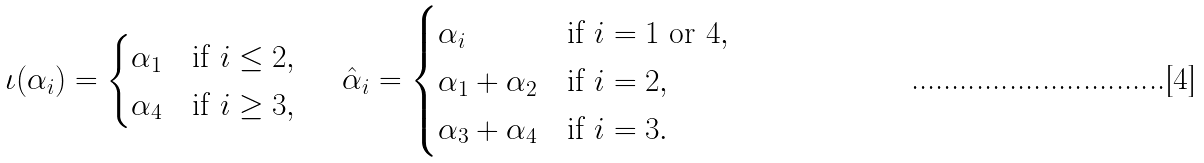Convert formula to latex. <formula><loc_0><loc_0><loc_500><loc_500>\iota ( \alpha _ { i } ) = \begin{cases} \alpha _ { 1 } & \text {if } i \leq 2 , \\ \alpha _ { 4 } & \text {if } i \geq 3 , \ \end{cases} \quad \hat { \alpha } _ { i } = \begin{cases} \alpha _ { i } & \text {if } i = 1 \text { or } 4 , \\ \alpha _ { 1 } + \alpha _ { 2 } & \text {if } i = 2 , \\ \alpha _ { 3 } + \alpha _ { 4 } & \text {if } i = 3 . \end{cases}</formula> 